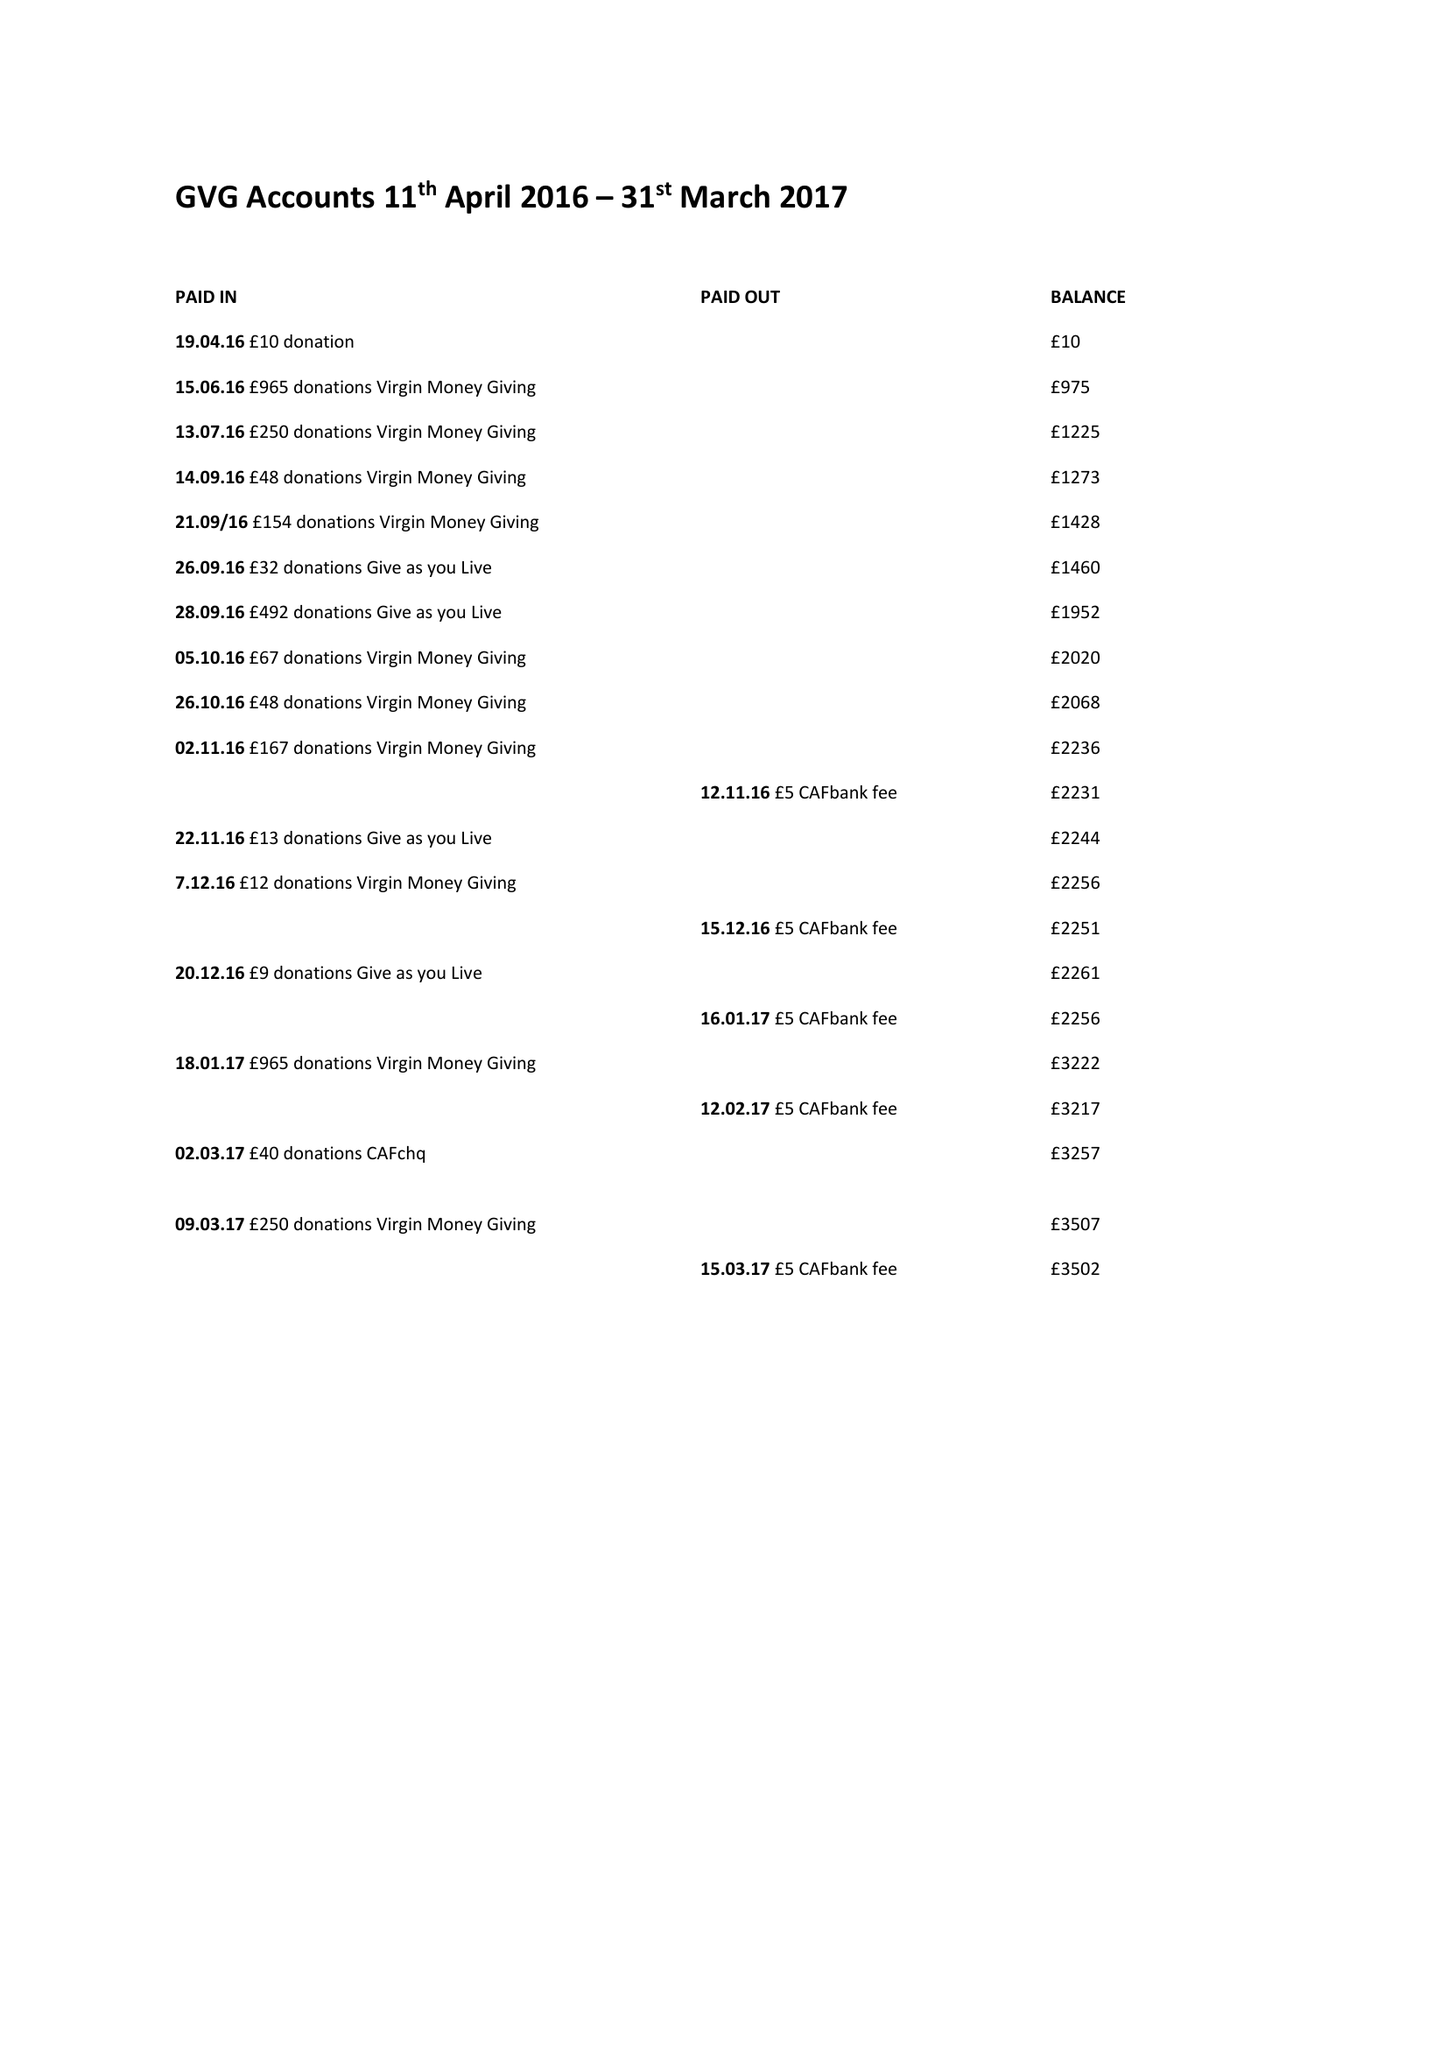What is the value for the report_date?
Answer the question using a single word or phrase. 2017-03-31 